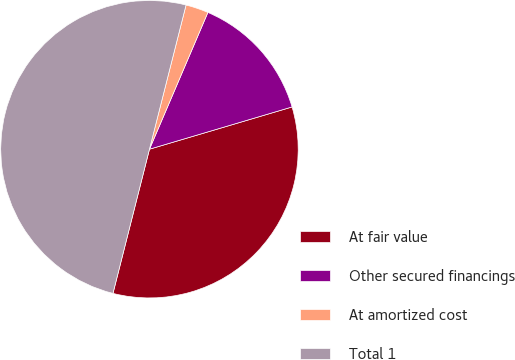Convert chart. <chart><loc_0><loc_0><loc_500><loc_500><pie_chart><fcel>At fair value<fcel>Other secured financings<fcel>At amortized cost<fcel>Total 1<nl><fcel>33.53%<fcel>13.99%<fcel>2.47%<fcel>50.01%<nl></chart> 